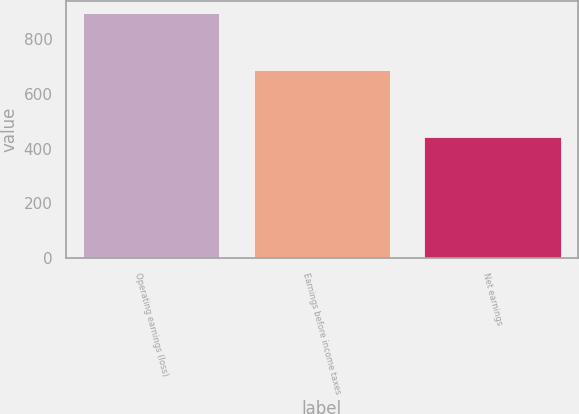Convert chart. <chart><loc_0><loc_0><loc_500><loc_500><bar_chart><fcel>Operating earnings (loss)<fcel>Earnings before income taxes<fcel>Net earnings<nl><fcel>895.7<fcel>687.7<fcel>440.7<nl></chart> 